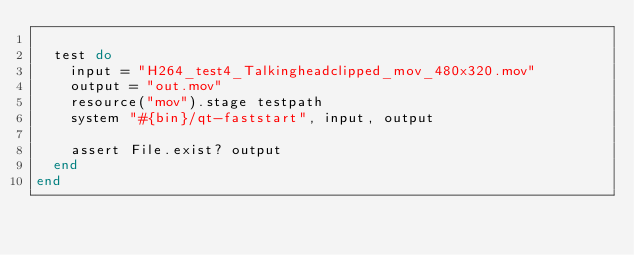<code> <loc_0><loc_0><loc_500><loc_500><_Ruby_>
  test do
    input = "H264_test4_Talkingheadclipped_mov_480x320.mov"
    output = "out.mov"
    resource("mov").stage testpath
    system "#{bin}/qt-faststart", input, output

    assert File.exist? output
  end
end
</code> 